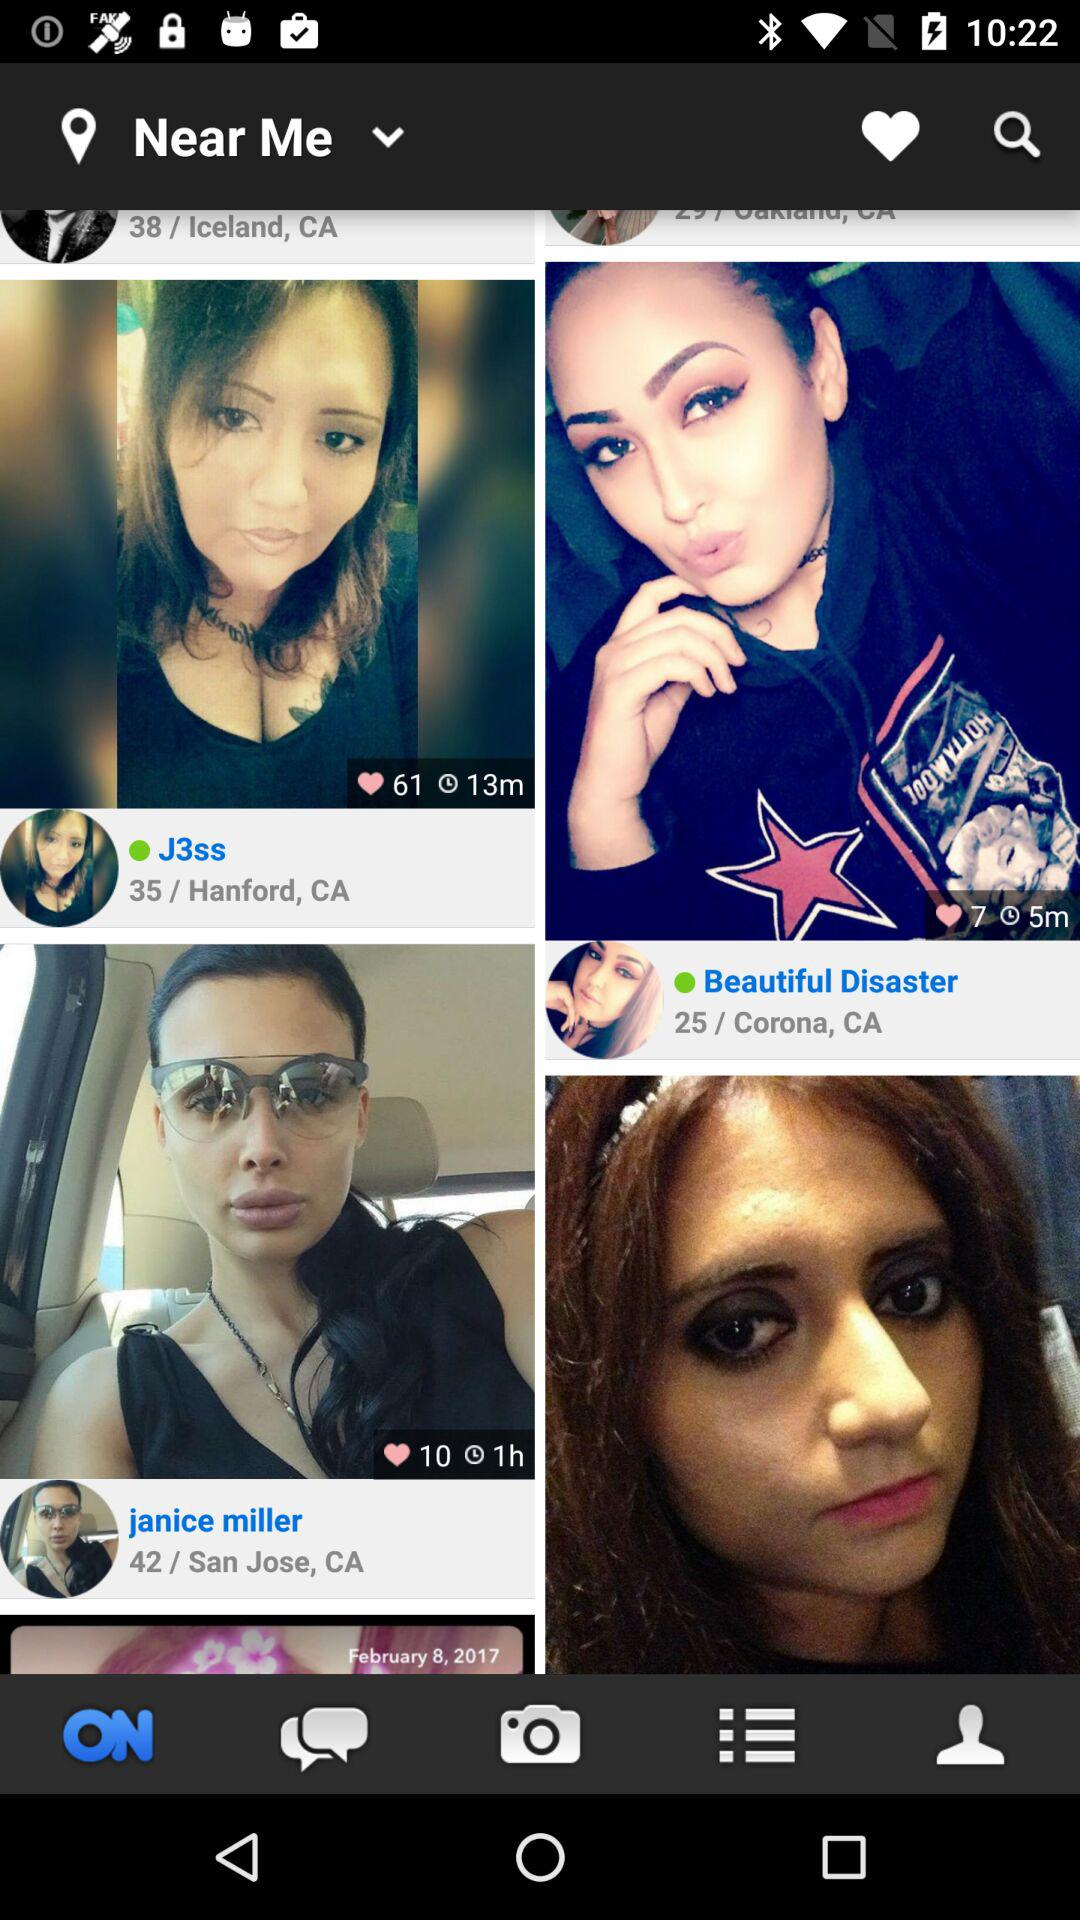How many likes are on the profile of "J3ss"? There are 61 likes on the profile of "J3ss". 